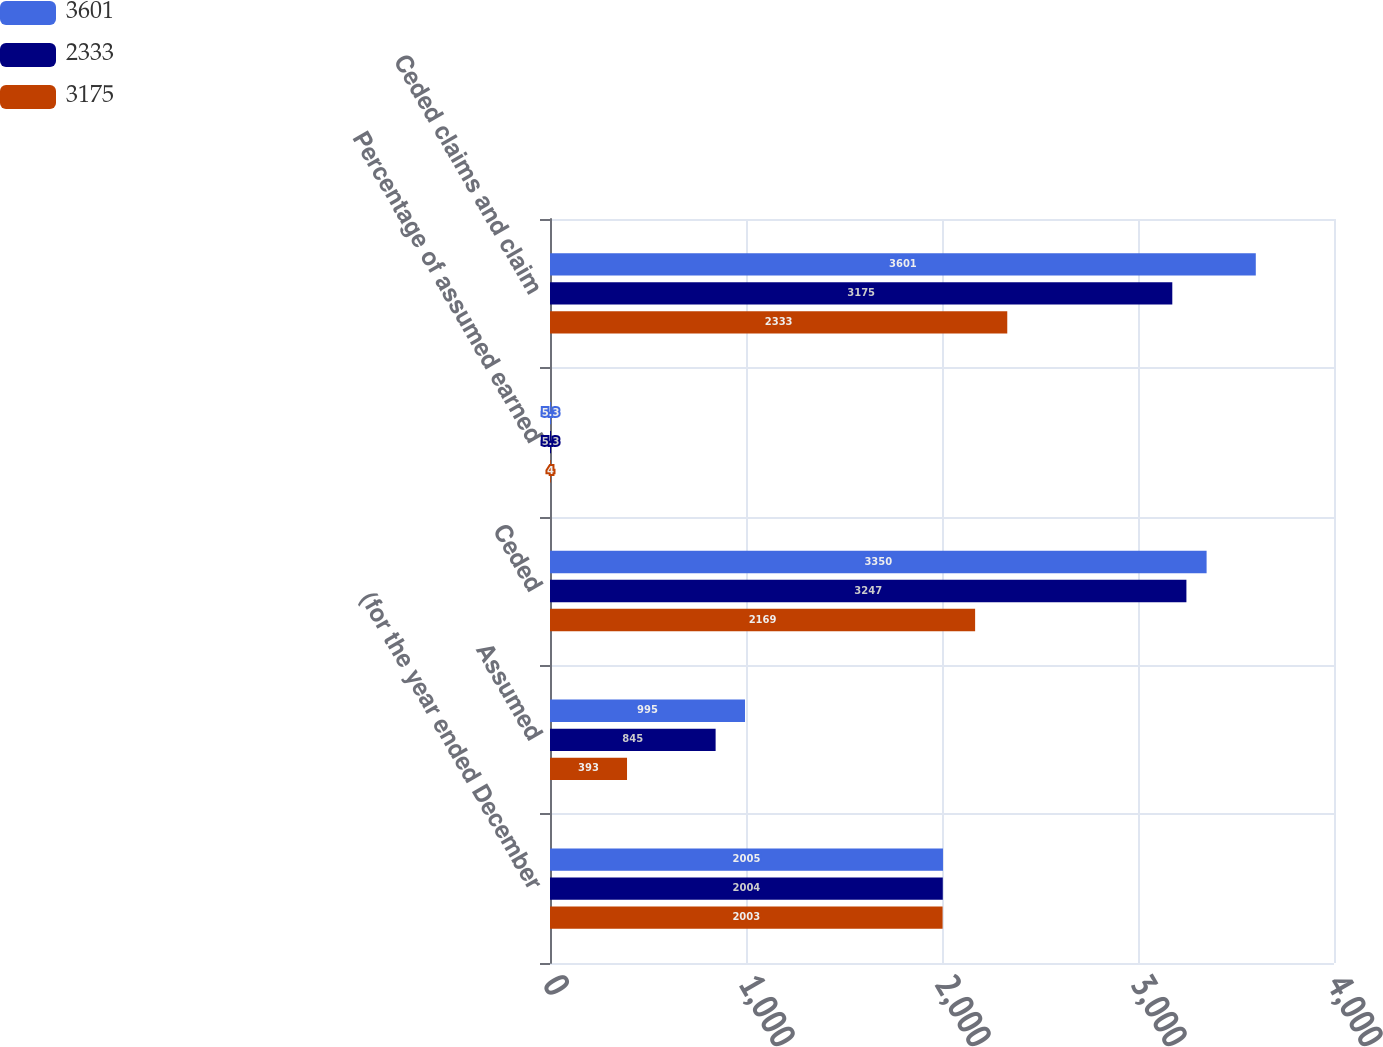<chart> <loc_0><loc_0><loc_500><loc_500><stacked_bar_chart><ecel><fcel>(for the year ended December<fcel>Assumed<fcel>Ceded<fcel>Percentage of assumed earned<fcel>Ceded claims and claim<nl><fcel>3601<fcel>2005<fcel>995<fcel>3350<fcel>5.3<fcel>3601<nl><fcel>2333<fcel>2004<fcel>845<fcel>3247<fcel>5.3<fcel>3175<nl><fcel>3175<fcel>2003<fcel>393<fcel>2169<fcel>4<fcel>2333<nl></chart> 